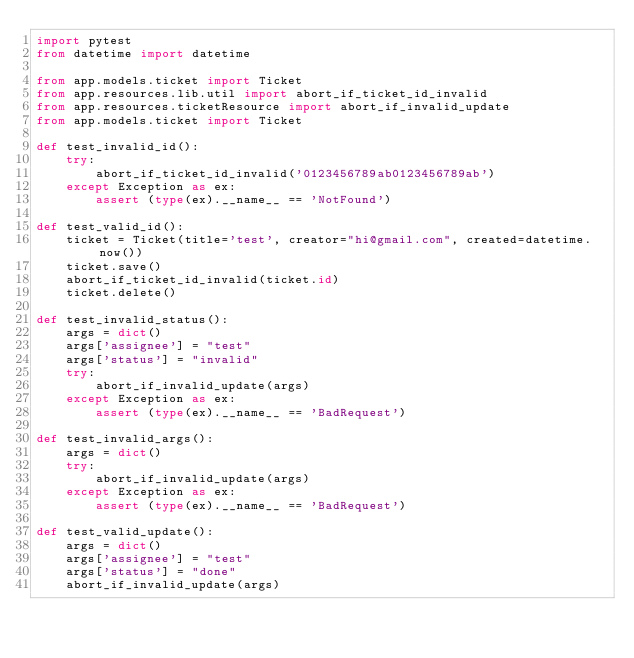<code> <loc_0><loc_0><loc_500><loc_500><_Python_>import pytest
from datetime import datetime

from app.models.ticket import Ticket
from app.resources.lib.util import abort_if_ticket_id_invalid
from app.resources.ticketResource import abort_if_invalid_update
from app.models.ticket import Ticket

def test_invalid_id():
	try:
		abort_if_ticket_id_invalid('0123456789ab0123456789ab')
	except Exception as ex:
		assert (type(ex).__name__ == 'NotFound')

def test_valid_id():
	ticket = Ticket(title='test', creator="hi@gmail.com", created=datetime.now())
	ticket.save()
	abort_if_ticket_id_invalid(ticket.id)
	ticket.delete()

def test_invalid_status():
	args = dict()
	args['assignee'] = "test"
	args['status'] = "invalid"
	try:
		abort_if_invalid_update(args)
	except Exception as ex:
		assert (type(ex).__name__ == 'BadRequest')

def test_invalid_args():
	args = dict()
	try:
		abort_if_invalid_update(args)
	except Exception as ex:
		assert (type(ex).__name__ == 'BadRequest')

def test_valid_update():
	args = dict()
	args['assignee'] = "test"
	args['status'] = "done"
	abort_if_invalid_update(args)	

</code> 